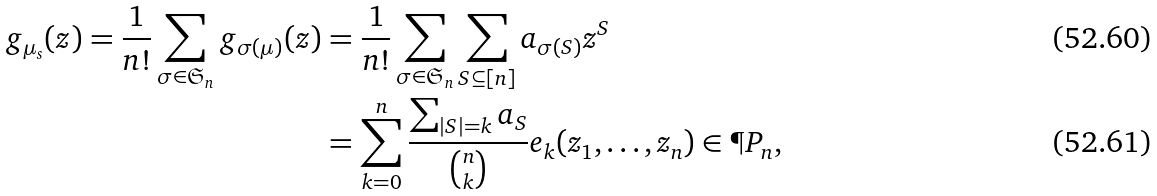Convert formula to latex. <formula><loc_0><loc_0><loc_500><loc_500>g _ { \mu _ { s } } ( z ) = \frac { 1 } { n ! } \sum _ { \sigma \in \mathfrak { S } _ { n } } g _ { \sigma ( \mu ) } ( z ) & = \frac { 1 } { n ! } \sum _ { \sigma \in \mathfrak { S } _ { n } } \sum _ { S \subseteq [ n ] } a _ { \sigma ( S ) } z ^ { S } \\ & = \sum _ { k = 0 } ^ { n } \frac { \sum _ { | S | = k } a _ { S } } { \binom { n } { k } } e _ { k } ( z _ { 1 } , \dots , z _ { n } ) \in \P P _ { n } ,</formula> 